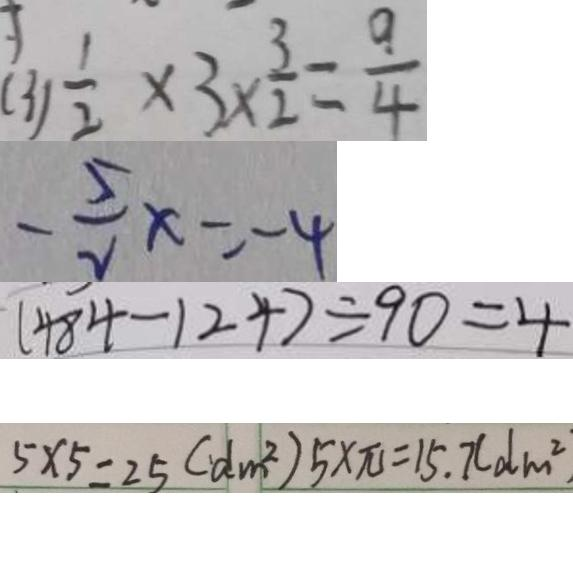<formula> <loc_0><loc_0><loc_500><loc_500>( 3 ) \frac { 1 } { 2 } \times 3 \times \frac { 3 } { 2 } = \frac { 9 } { 4 } 
 - \frac { 5 } { 2 } x = - 4 
 ( 4 8 4 - 1 2 4 ) \div 9 0 = 4 
 5 \times 5 = 2 5 ( d m ^ { 2 } ) 5 \times \pi = 1 5 . 7 ( d m ^ { 2 }</formula> 